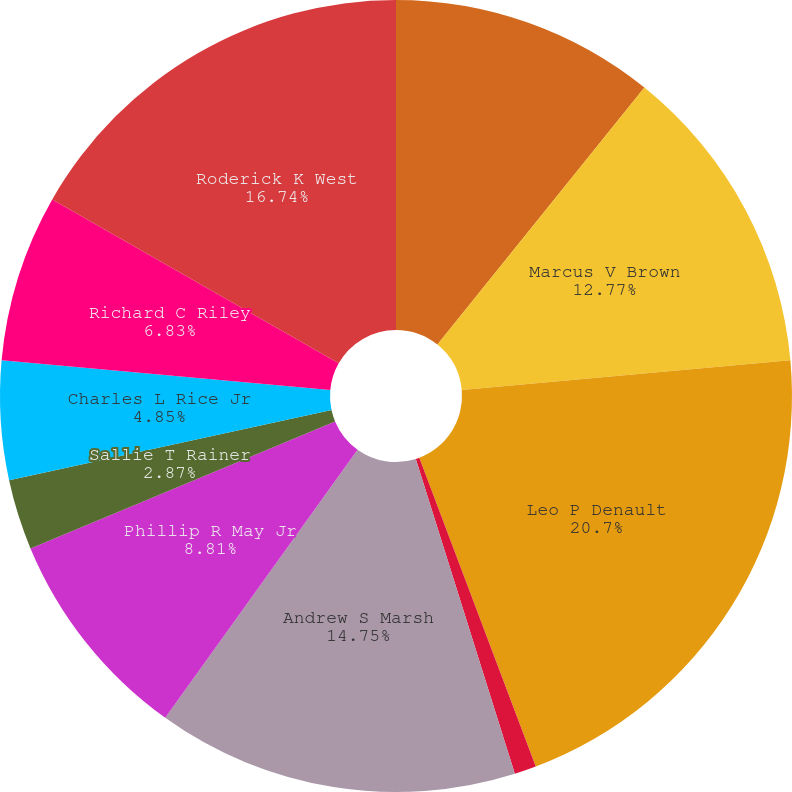Convert chart. <chart><loc_0><loc_0><loc_500><loc_500><pie_chart><fcel>A Christopher Bakken III (1)<fcel>Marcus V Brown<fcel>Leo P Denault<fcel>Haley R Fisackerly<fcel>Andrew S Marsh<fcel>Phillip R May Jr<fcel>Sallie T Rainer<fcel>Charles L Rice Jr<fcel>Richard C Riley<fcel>Roderick K West<nl><fcel>10.79%<fcel>12.77%<fcel>20.69%<fcel>0.89%<fcel>14.75%<fcel>8.81%<fcel>2.87%<fcel>4.85%<fcel>6.83%<fcel>16.73%<nl></chart> 